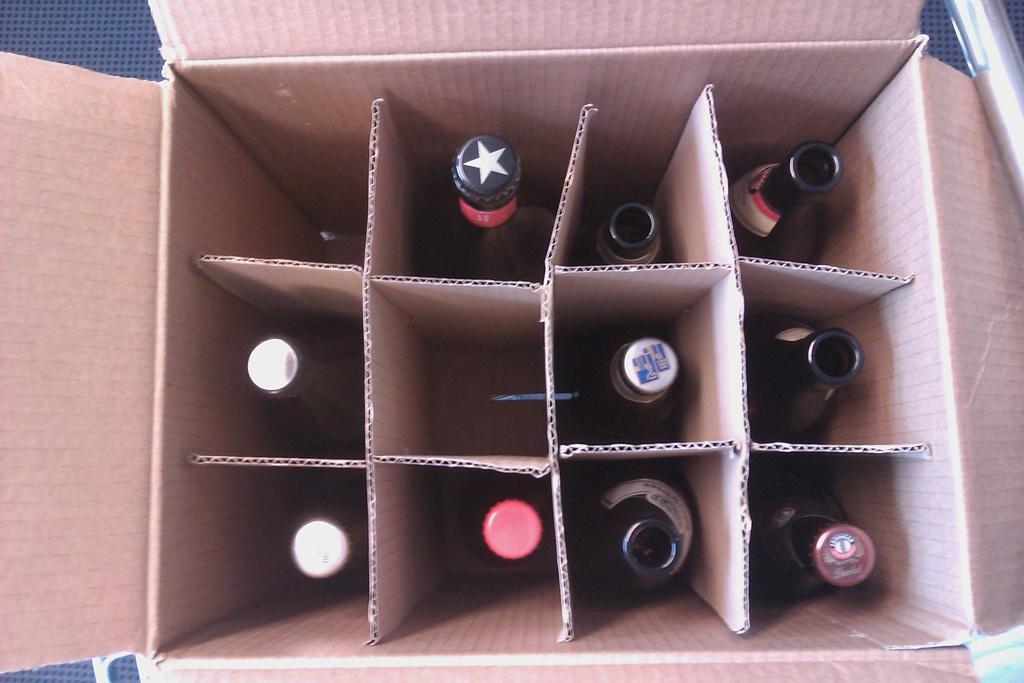In one or two sentences, can you explain what this image depicts? This picture consists of a box and I can see there are few bottles kept in the box 